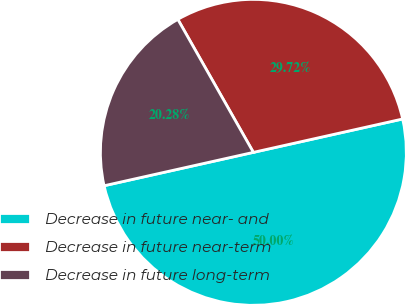<chart> <loc_0><loc_0><loc_500><loc_500><pie_chart><fcel>Decrease in future near- and<fcel>Decrease in future near-term<fcel>Decrease in future long-term<nl><fcel>50.0%<fcel>29.72%<fcel>20.28%<nl></chart> 